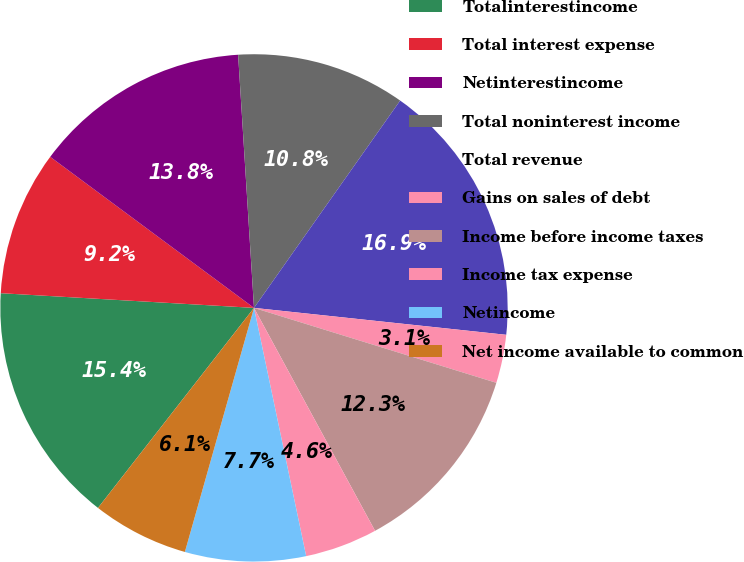Convert chart to OTSL. <chart><loc_0><loc_0><loc_500><loc_500><pie_chart><fcel>Totalinterestincome<fcel>Total interest expense<fcel>Netinterestincome<fcel>Total noninterest income<fcel>Total revenue<fcel>Gains on sales of debt<fcel>Income before income taxes<fcel>Income tax expense<fcel>Netincome<fcel>Net income available to common<nl><fcel>15.38%<fcel>9.23%<fcel>13.85%<fcel>10.77%<fcel>16.92%<fcel>3.08%<fcel>12.31%<fcel>4.62%<fcel>7.69%<fcel>6.15%<nl></chart> 